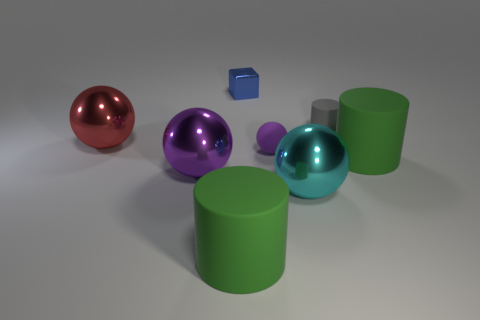What number of purple shiny things are the same size as the gray matte object?
Ensure brevity in your answer.  0. What number of objects are on the left side of the small gray object and in front of the tiny matte cylinder?
Offer a terse response. 5. Do the matte cylinder that is behind the red metal sphere and the big cyan thing have the same size?
Make the answer very short. No. Is there a big shiny object that has the same color as the cube?
Keep it short and to the point. No. There is a red object that is the same material as the blue block; what size is it?
Ensure brevity in your answer.  Large. Are there more tiny blue metal blocks that are in front of the tiny blue object than cyan metal spheres that are in front of the cyan metal sphere?
Your answer should be very brief. No. How many other things are made of the same material as the large cyan object?
Make the answer very short. 3. Is the material of the large green object in front of the cyan shiny ball the same as the tiny gray object?
Keep it short and to the point. Yes. There is a tiny gray matte thing; what shape is it?
Provide a short and direct response. Cylinder. Is the number of metal balls to the right of the blue block greater than the number of blue metallic cylinders?
Provide a succinct answer. Yes. 